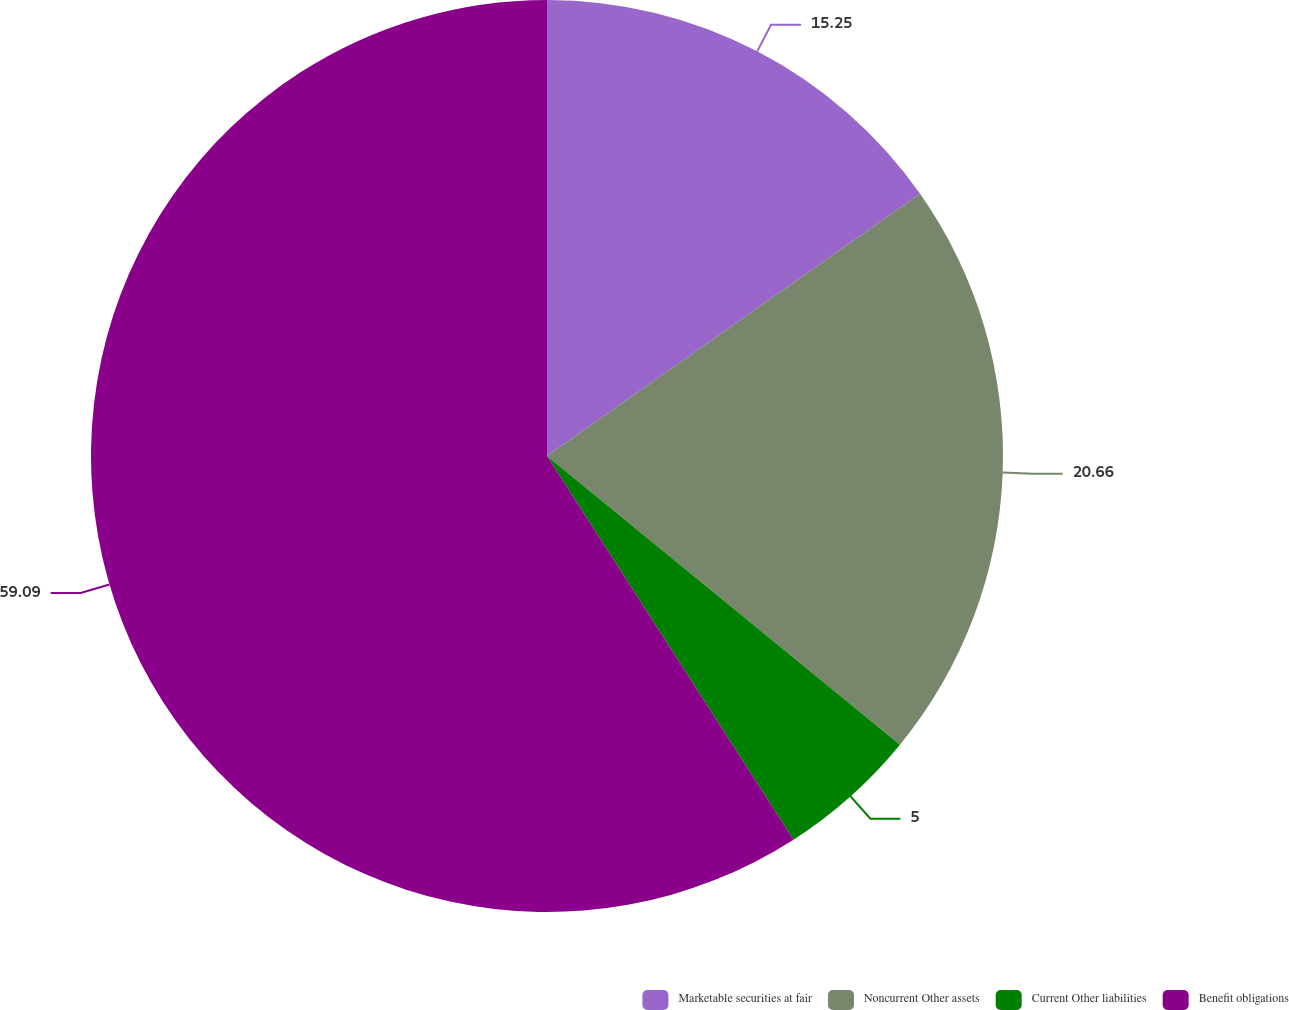<chart> <loc_0><loc_0><loc_500><loc_500><pie_chart><fcel>Marketable securities at fair<fcel>Noncurrent Other assets<fcel>Current Other liabilities<fcel>Benefit obligations<nl><fcel>15.25%<fcel>20.66%<fcel>5.0%<fcel>59.09%<nl></chart> 